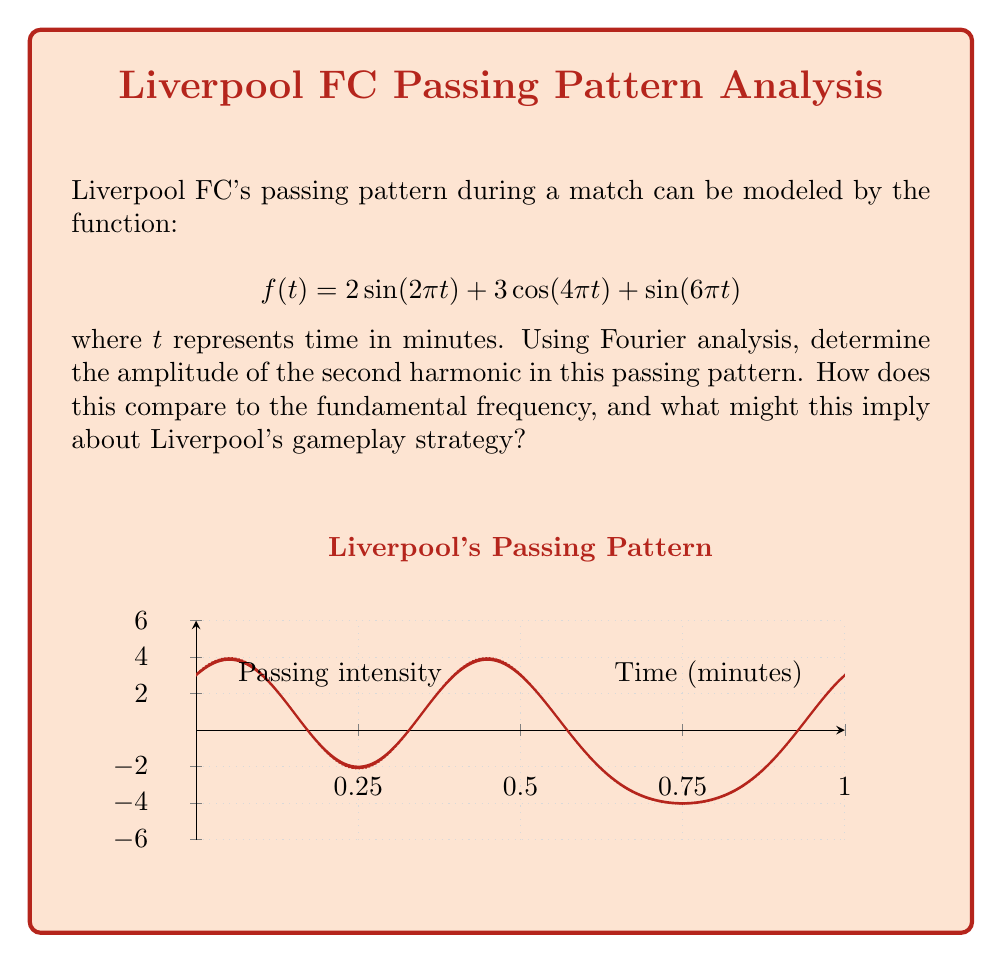Can you solve this math problem? To solve this problem, we need to analyze the given function in terms of its Fourier components:

1) The given function is: 
   $$f(t) = 2\sin(2\pi t) + 3\cos(4\pi t) + \sin(6\pi t)$$

2) In Fourier analysis, the fundamental frequency is the lowest frequency in the signal. Here, it corresponds to $2\pi t$, so the fundamental frequency is 1 Hz.

3) The second harmonic would have twice the frequency of the fundamental, which is $4\pi t$.

4) In the given function, the term corresponding to the second harmonic is $3\cos(4\pi t)$.

5) The amplitude of this term is 3.

6) To compare with the fundamental:
   - The fundamental term is $2\sin(2\pi t)$, with amplitude 2.
   - The ratio of second harmonic to fundamental amplitude is 3:2 or 1.5:1.

7) This higher amplitude in the second harmonic suggests that Liverpool's passing pattern has a stronger component at twice the base frequency of their play.

8) In terms of gameplay strategy, this could imply that Liverpool tends to alternate between slower build-up play (fundamental frequency) and quicker, more intense passing sequences (second harmonic). The stronger second harmonic might indicate a preference for faster-paced, high-pressure phases of play.
Answer: Amplitude of second harmonic: 3; Ratio to fundamental: 1.5:1 